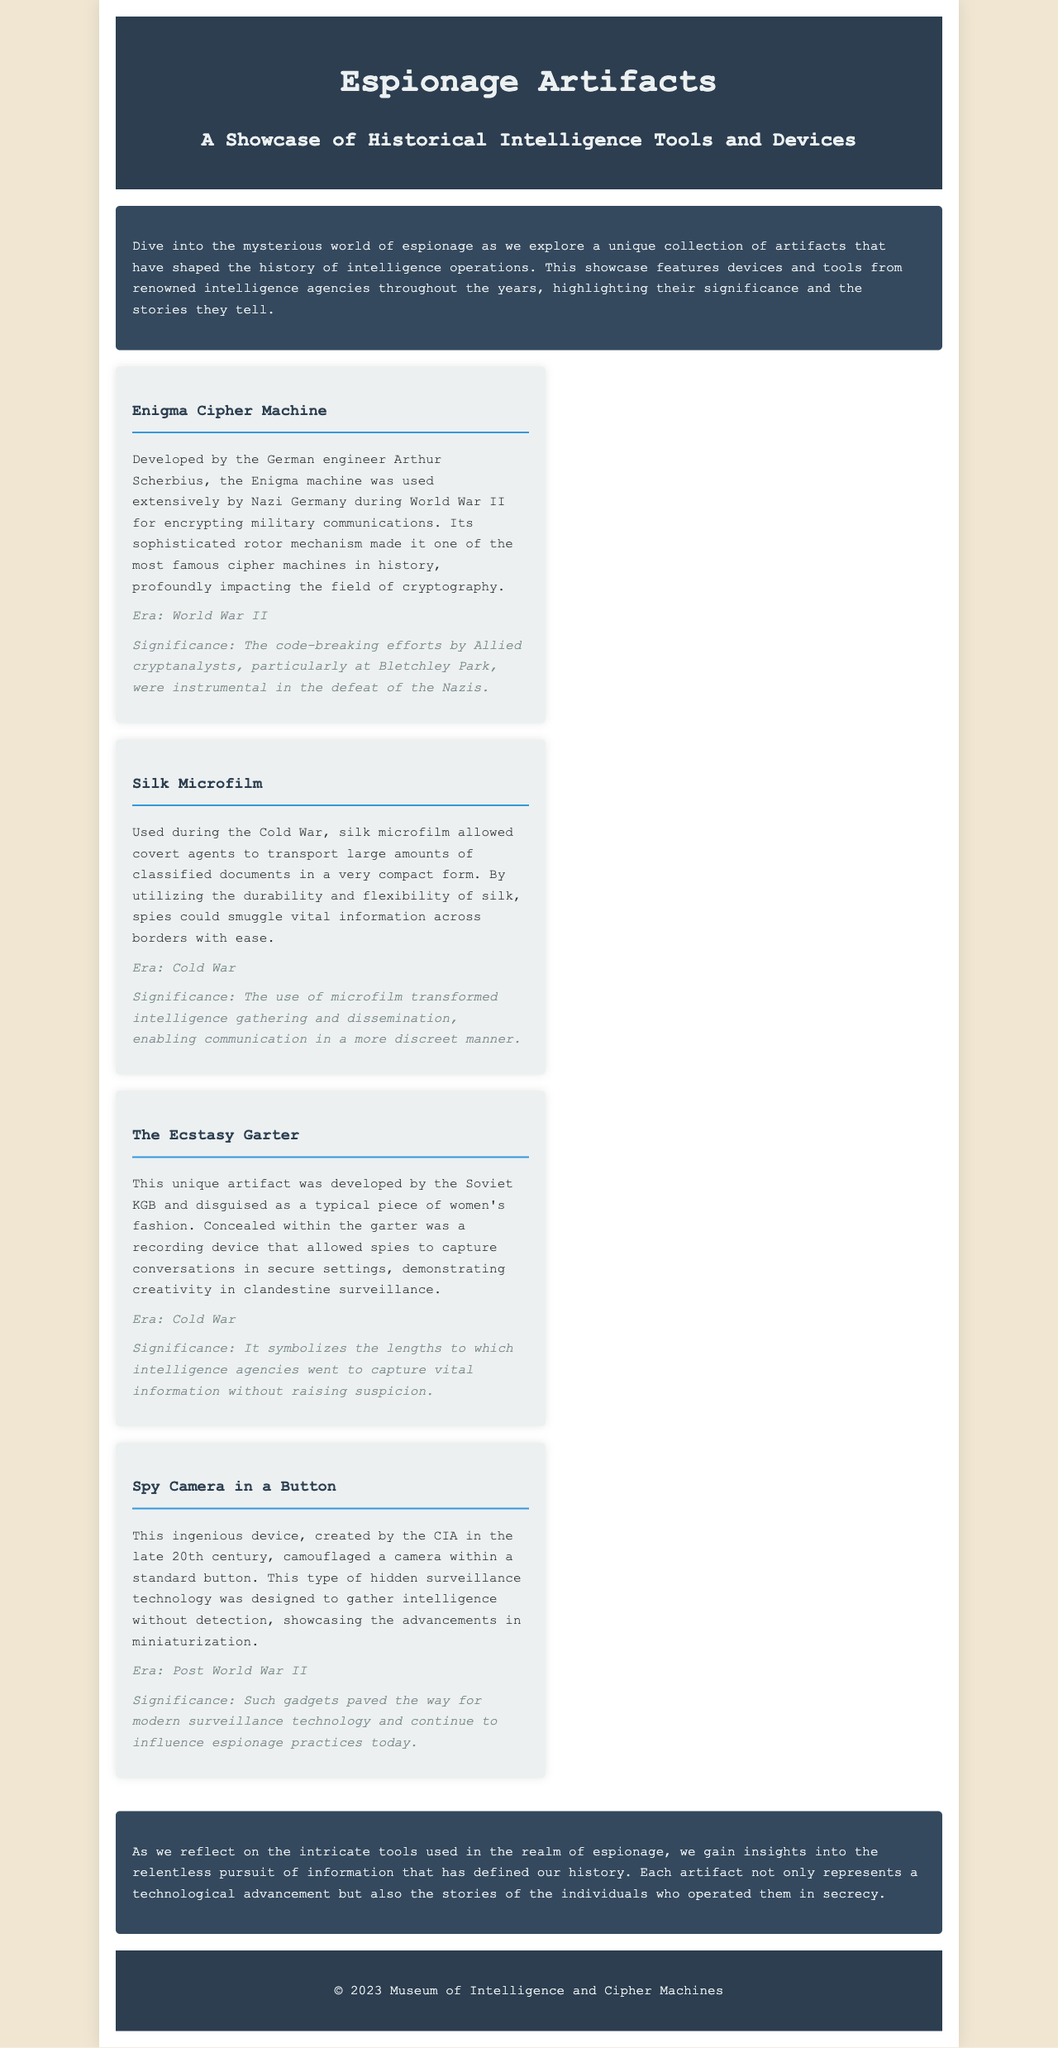What is the title of the brochure? The title of the brochure is stated prominently at the beginning of the document.
Answer: Espionage Artifacts Who developed the Enigma Cipher Machine? The developer of the Enigma Cipher Machine is mentioned within its description.
Answer: Arthur Scherbius What era does the Silk Microfilm belong to? The era associated with Silk Microfilm is indicated in its description.
Answer: Cold War What unique feature does The Ecstasy Garter have? The unique feature of The Ecstasy Garter is outlined in its details, relevant to its function.
Answer: A recording device What impact did the code-breaking efforts at Bletchley Park have? The impact of the code-breaking efforts is summarized in the significance section of the Enigma description.
Answer: Instrumental in the defeat of the Nazis Which agency created the Spy Camera in a Button? The agency responsible for creating the Spy Camera in a Button is mentioned in the description.
Answer: CIA What is the primary focus of this brochure? The primary focus of the brochure is conveyed in the introductory paragraph.
Answer: Historical Intelligence Tools and Devices How many artifacts are showcased in the document? The total number of artifacts can be counted from the artifact section of the document.
Answer: Four 